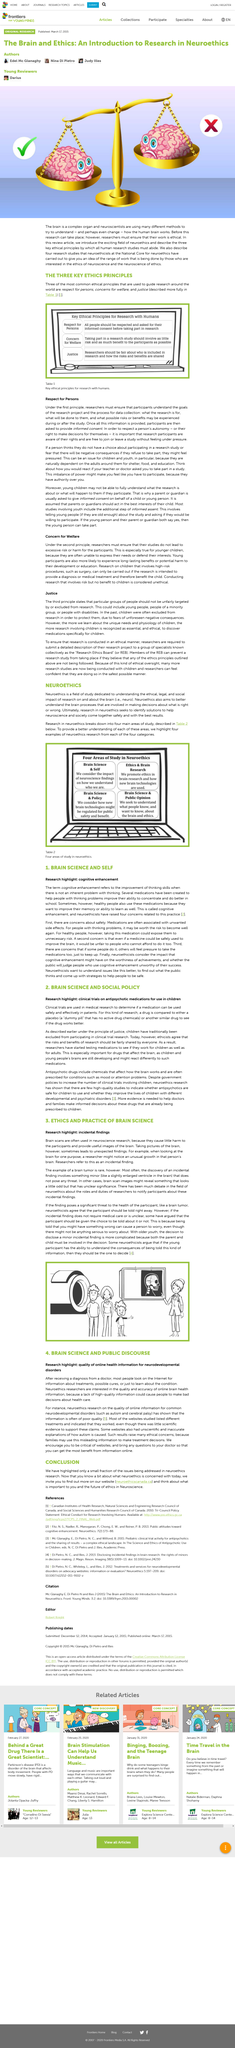Outline some significant characteristics in this image. The research highlight in this article is the potential for cognitive enhancement using a modified version of the Moodle platform, which is an online learning management system. The National Core for Neuroethics contributes to the neuroethics research field. A pill without active drug ingredients is known as a placebo. The area of study depicted in the Figure at the top right-hand side is Ethics and Brain Research. Neuroethics aims to explore the neural mechanisms that underpin moral decision-making, with the goal of promoting a deeper understanding of the complex interplay between the brain, behavior, and ethical values. 